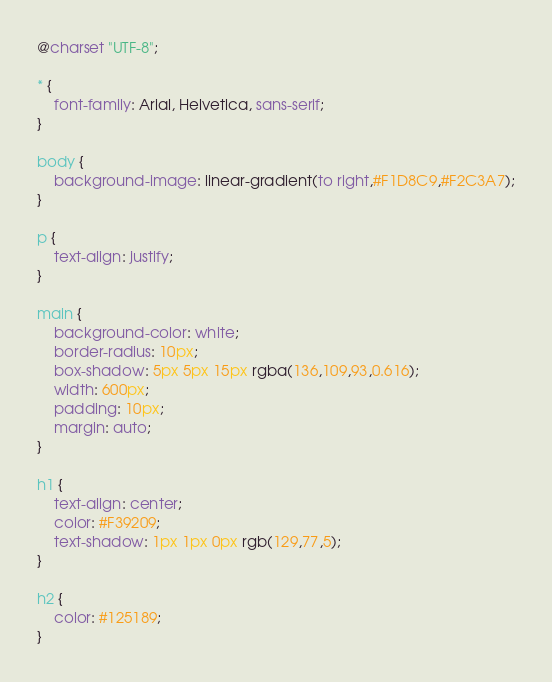Convert code to text. <code><loc_0><loc_0><loc_500><loc_500><_CSS_>@charset "UTF-8";

* {
    font-family: Arial, Helvetica, sans-serif;
}

body {
    background-image: linear-gradient(to right,#F1D8C9,#F2C3A7);
}

p {
    text-align: justify;
}

main {
    background-color: white;
    border-radius: 10px;
    box-shadow: 5px 5px 15px rgba(136,109,93,0.616);
    width: 600px;
    padding: 10px;
    margin: auto;
}

h1 {
    text-align: center;
    color: #F39209; 
    text-shadow: 1px 1px 0px rgb(129,77,5);
}

h2 {
    color: #125189;
}</code> 